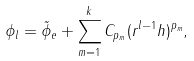<formula> <loc_0><loc_0><loc_500><loc_500>\phi _ { l } = \tilde { \phi } _ { e } + \sum _ { m = 1 } ^ { k } C _ { p _ { m } } ( r ^ { l - 1 } h ) ^ { p _ { m } } ,</formula> 